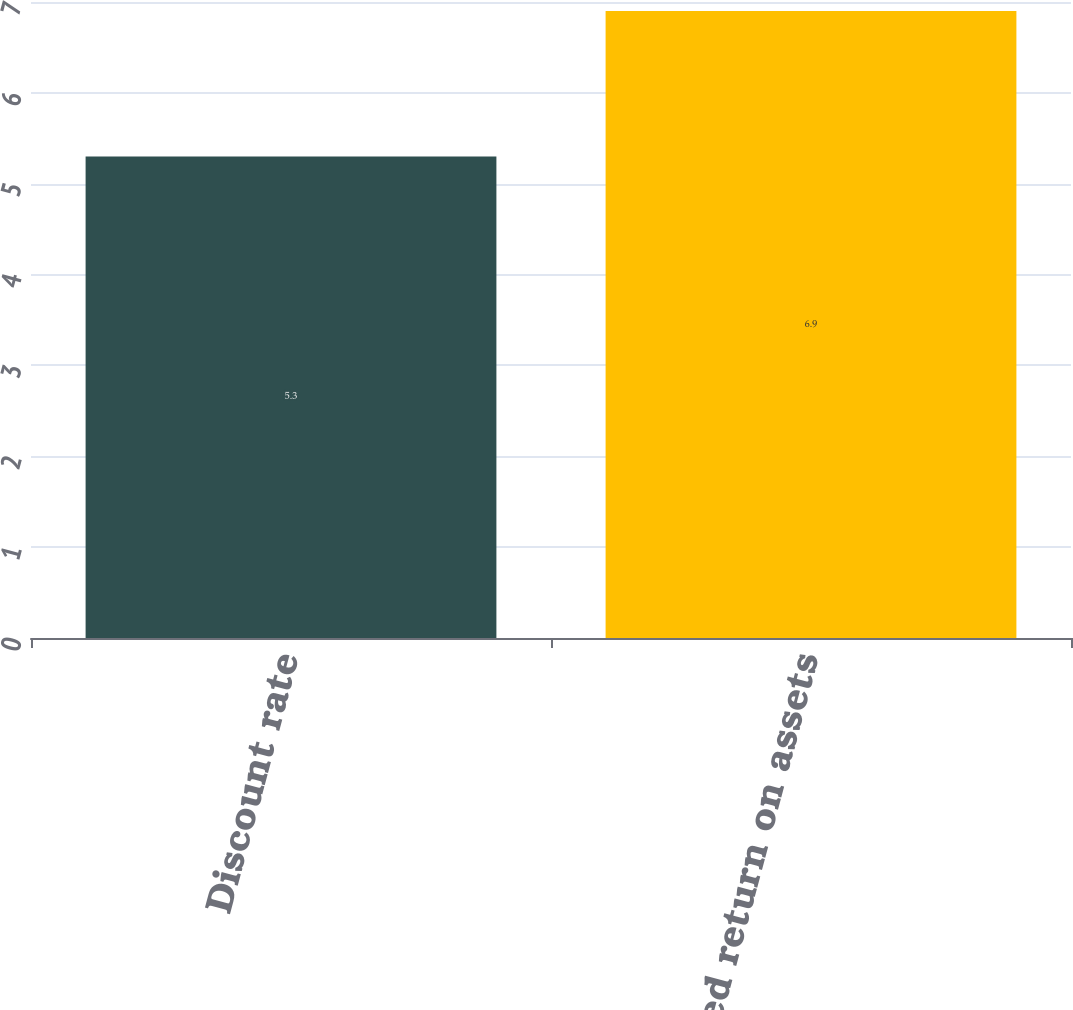<chart> <loc_0><loc_0><loc_500><loc_500><bar_chart><fcel>Discount rate<fcel>Expected return on assets<nl><fcel>5.3<fcel>6.9<nl></chart> 